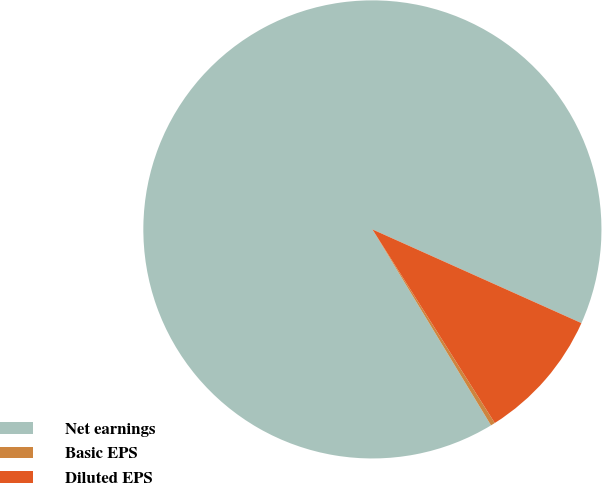Convert chart. <chart><loc_0><loc_0><loc_500><loc_500><pie_chart><fcel>Net earnings<fcel>Basic EPS<fcel>Diluted EPS<nl><fcel>90.37%<fcel>0.31%<fcel>9.32%<nl></chart> 